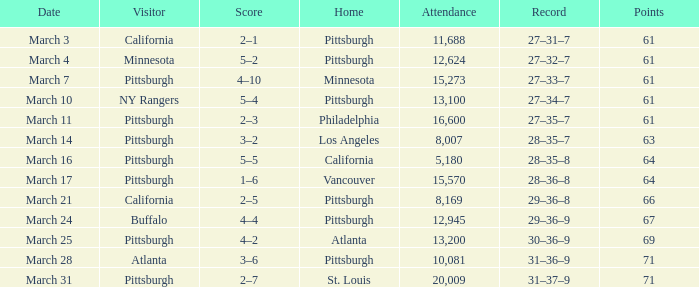Would you be able to parse every entry in this table? {'header': ['Date', 'Visitor', 'Score', 'Home', 'Attendance', 'Record', 'Points'], 'rows': [['March 3', 'California', '2–1', 'Pittsburgh', '11,688', '27–31–7', '61'], ['March 4', 'Minnesota', '5–2', 'Pittsburgh', '12,624', '27–32–7', '61'], ['March 7', 'Pittsburgh', '4–10', 'Minnesota', '15,273', '27–33–7', '61'], ['March 10', 'NY Rangers', '5–4', 'Pittsburgh', '13,100', '27–34–7', '61'], ['March 11', 'Pittsburgh', '2–3', 'Philadelphia', '16,600', '27–35–7', '61'], ['March 14', 'Pittsburgh', '3–2', 'Los Angeles', '8,007', '28–35–7', '63'], ['March 16', 'Pittsburgh', '5–5', 'California', '5,180', '28–35–8', '64'], ['March 17', 'Pittsburgh', '1–6', 'Vancouver', '15,570', '28–36–8', '64'], ['March 21', 'California', '2–5', 'Pittsburgh', '8,169', '29–36–8', '66'], ['March 24', 'Buffalo', '4–4', 'Pittsburgh', '12,945', '29–36–9', '67'], ['March 25', 'Pittsburgh', '4–2', 'Atlanta', '13,200', '30–36–9', '69'], ['March 28', 'Atlanta', '3–6', 'Pittsburgh', '10,081', '31–36–9', '71'], ['March 31', 'Pittsburgh', '2–7', 'St. Louis', '20,009', '31–37–9', '71']]} With 61 points, what was the outcome of the home game in pittsburgh on march 3? 2–1. 